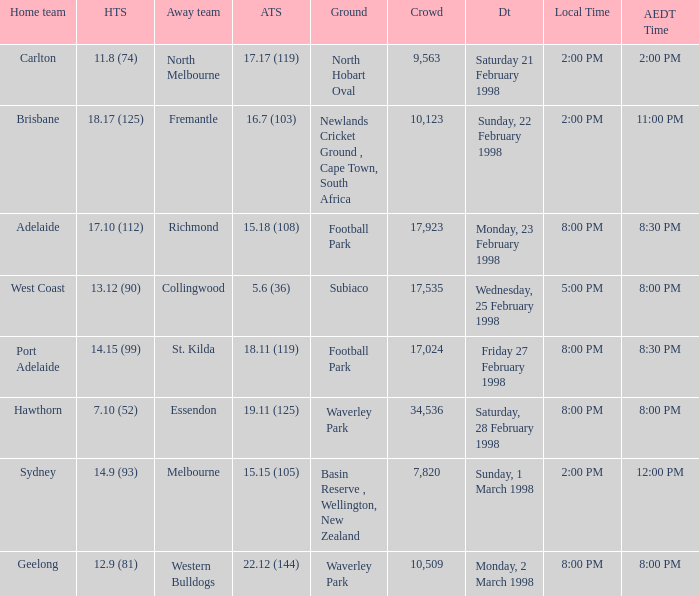Can you parse all the data within this table? {'header': ['Home team', 'HTS', 'Away team', 'ATS', 'Ground', 'Crowd', 'Dt', 'Local Time', 'AEDT Time'], 'rows': [['Carlton', '11.8 (74)', 'North Melbourne', '17.17 (119)', 'North Hobart Oval', '9,563', 'Saturday 21 February 1998', '2:00 PM', '2:00 PM'], ['Brisbane', '18.17 (125)', 'Fremantle', '16.7 (103)', 'Newlands Cricket Ground , Cape Town, South Africa', '10,123', 'Sunday, 22 February 1998', '2:00 PM', '11:00 PM'], ['Adelaide', '17.10 (112)', 'Richmond', '15.18 (108)', 'Football Park', '17,923', 'Monday, 23 February 1998', '8:00 PM', '8:30 PM'], ['West Coast', '13.12 (90)', 'Collingwood', '5.6 (36)', 'Subiaco', '17,535', 'Wednesday, 25 February 1998', '5:00 PM', '8:00 PM'], ['Port Adelaide', '14.15 (99)', 'St. Kilda', '18.11 (119)', 'Football Park', '17,024', 'Friday 27 February 1998', '8:00 PM', '8:30 PM'], ['Hawthorn', '7.10 (52)', 'Essendon', '19.11 (125)', 'Waverley Park', '34,536', 'Saturday, 28 February 1998', '8:00 PM', '8:00 PM'], ['Sydney', '14.9 (93)', 'Melbourne', '15.15 (105)', 'Basin Reserve , Wellington, New Zealand', '7,820', 'Sunday, 1 March 1998', '2:00 PM', '12:00 PM'], ['Geelong', '12.9 (81)', 'Western Bulldogs', '22.12 (144)', 'Waverley Park', '10,509', 'Monday, 2 March 1998', '8:00 PM', '8:00 PM']]} Name the AEDT Time which has a Local Time of 8:00 pm, and a Away team score of 22.12 (144)? 8:00 PM. 